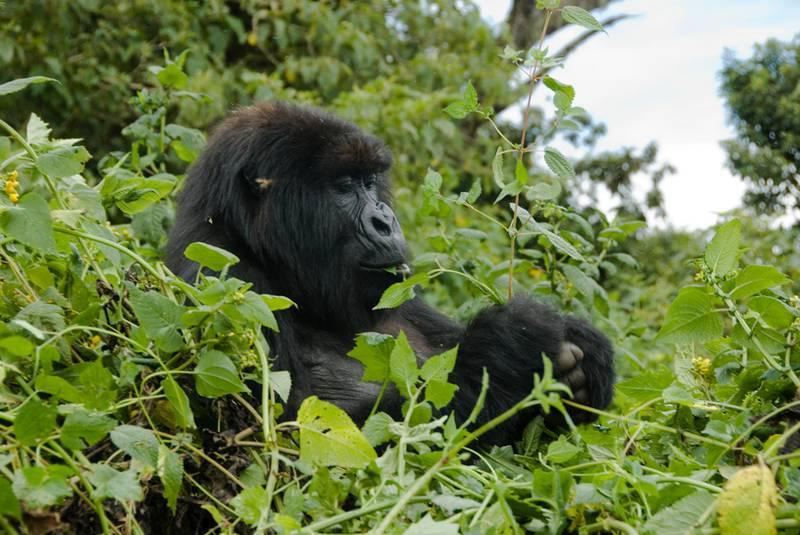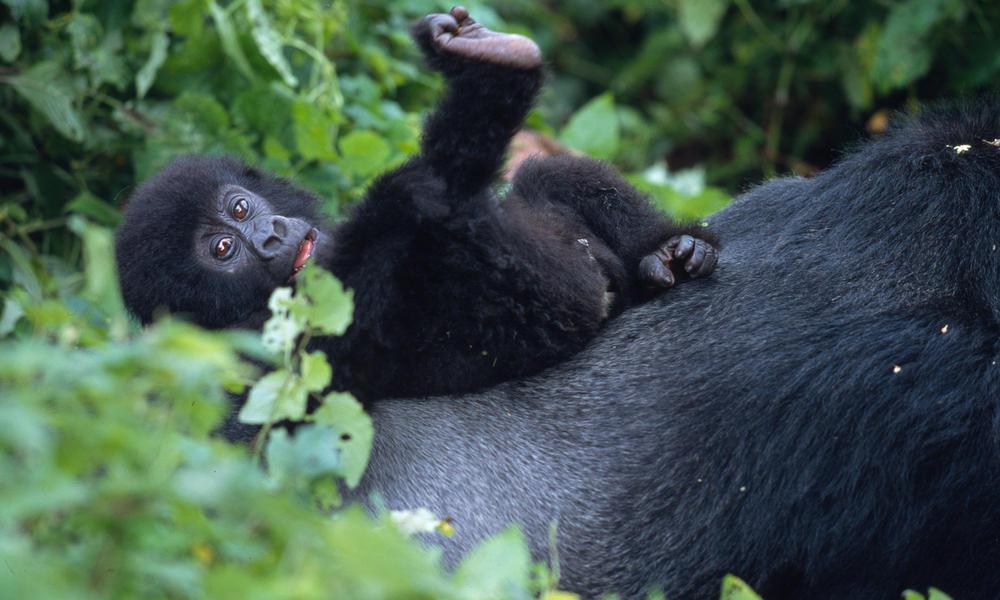The first image is the image on the left, the second image is the image on the right. Evaluate the accuracy of this statement regarding the images: "The gorilla in the right image is chewing on a fibrous stalk.". Is it true? Answer yes or no. No. The first image is the image on the left, the second image is the image on the right. For the images displayed, is the sentence "One of the photos contains more than one animal." factually correct? Answer yes or no. Yes. 